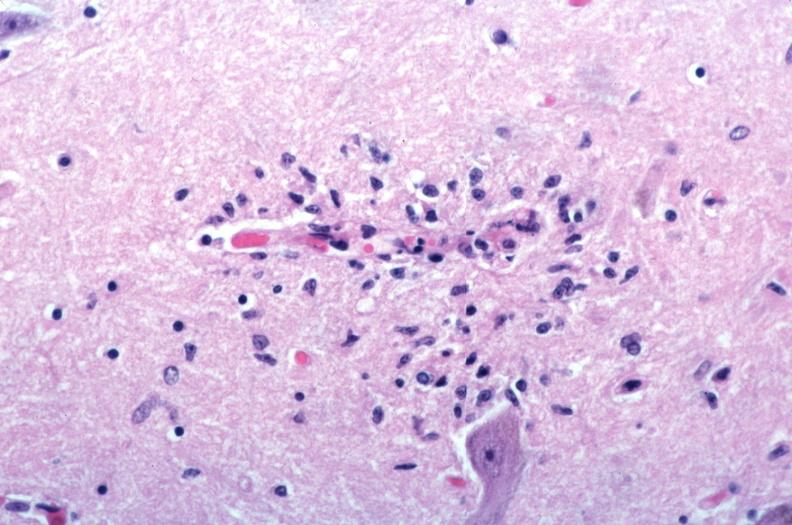s syndactyly present?
Answer the question using a single word or phrase. No 